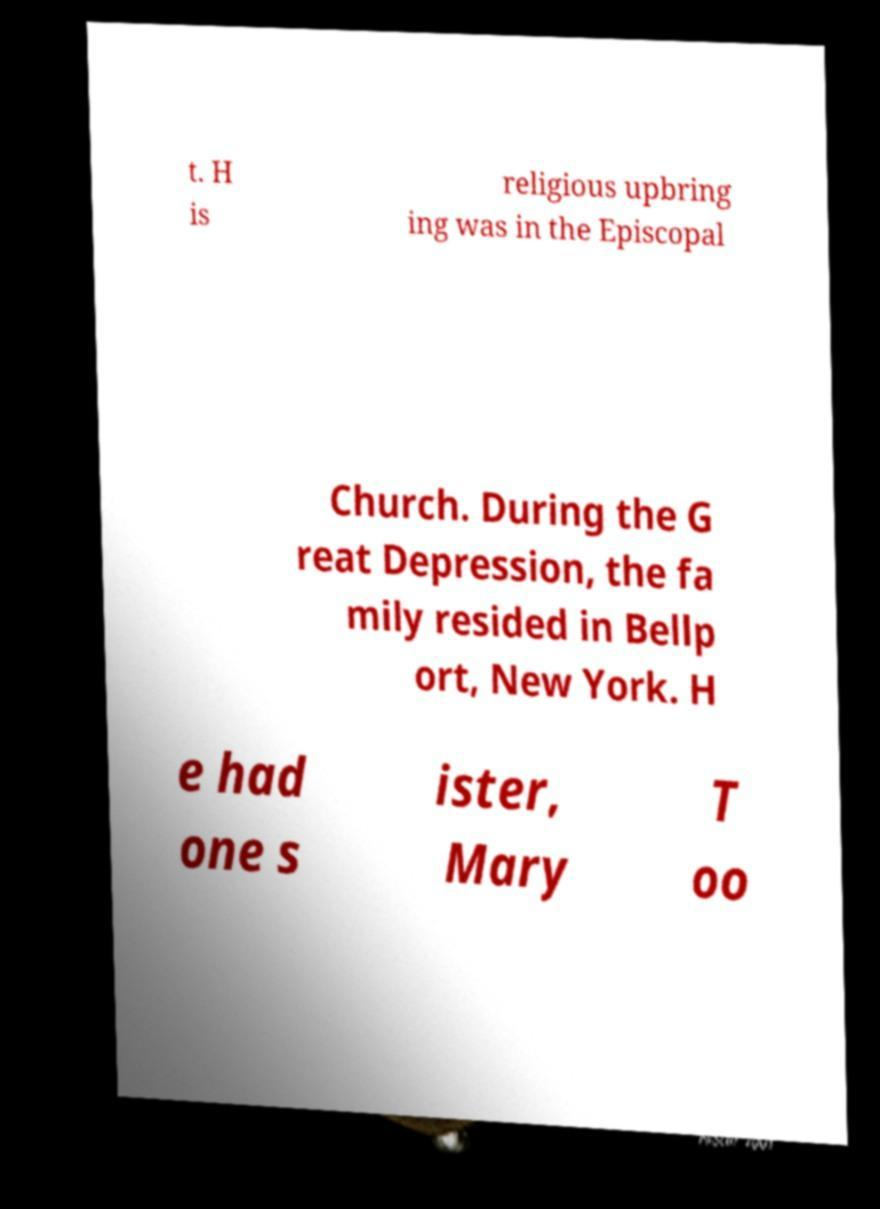Can you read and provide the text displayed in the image?This photo seems to have some interesting text. Can you extract and type it out for me? t. H is religious upbring ing was in the Episcopal Church. During the G reat Depression, the fa mily resided in Bellp ort, New York. H e had one s ister, Mary T oo 